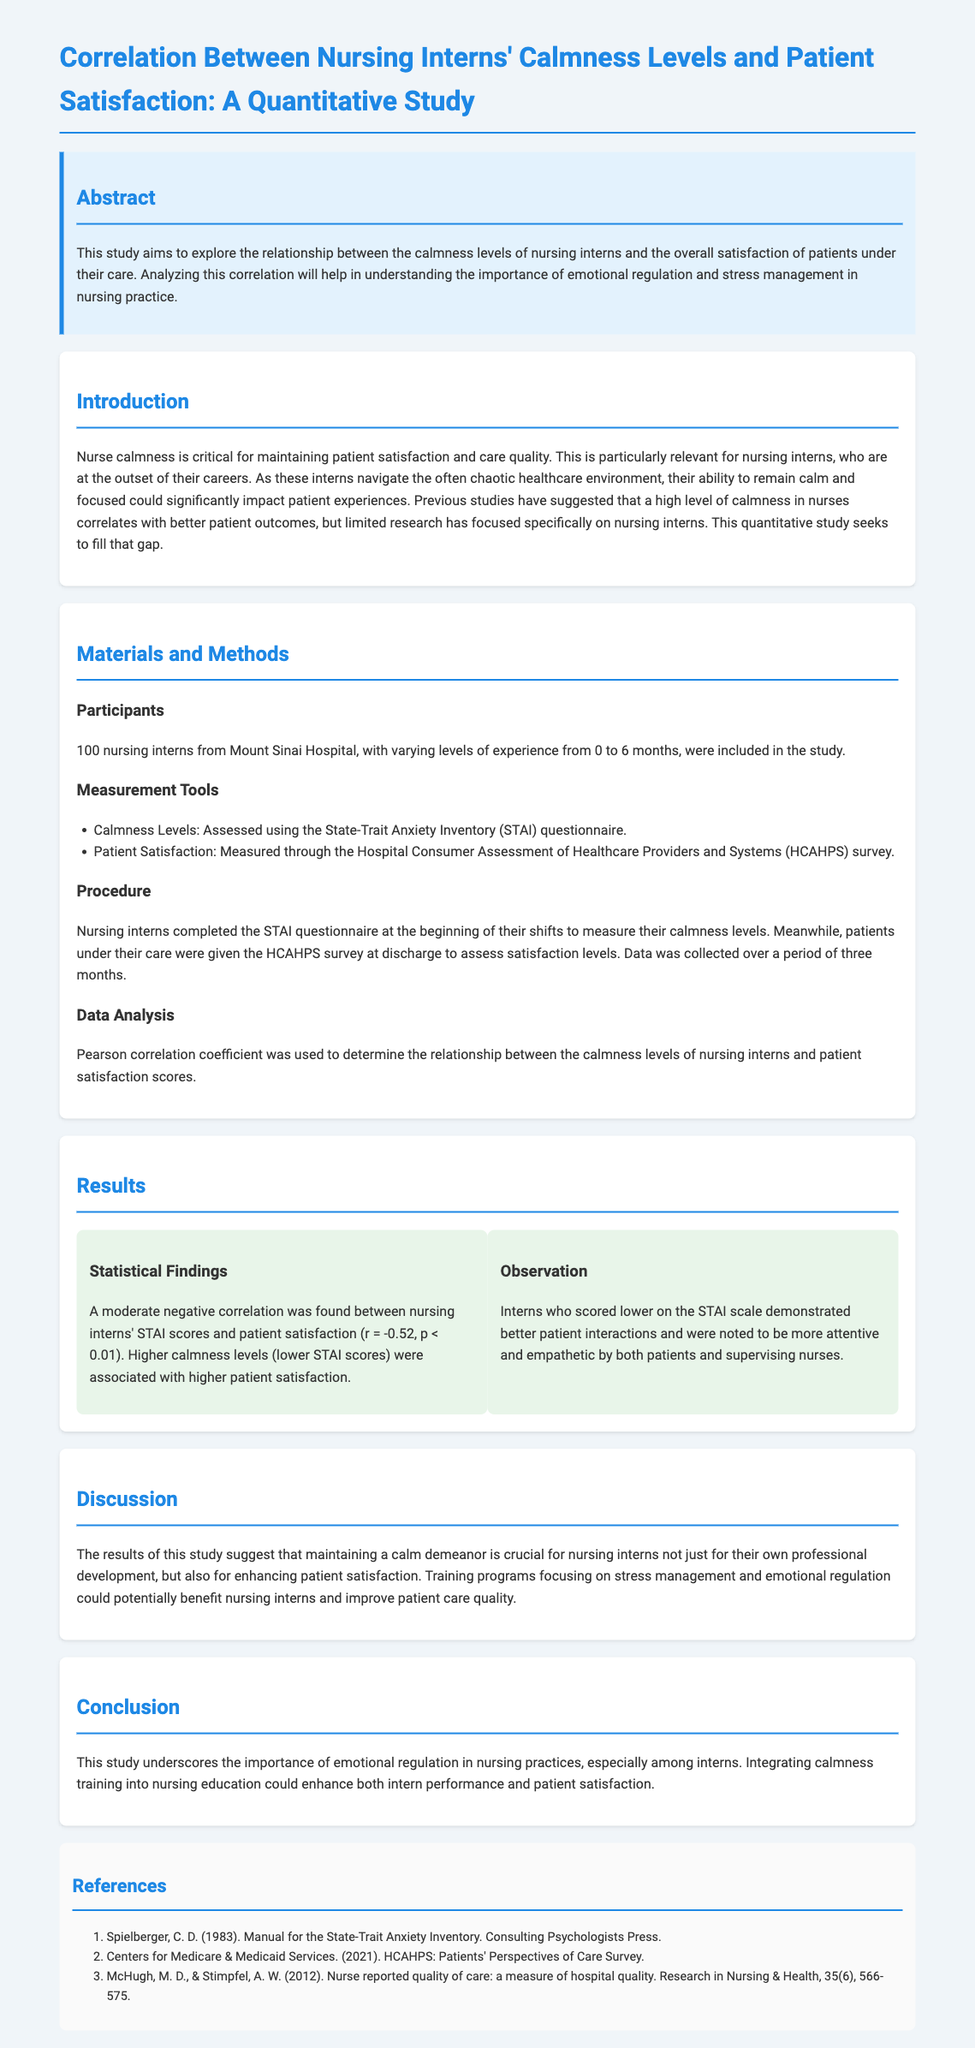what was the main objective of the study? The study aims to explore the relationship between calmness levels of nursing interns and patient satisfaction.
Answer: relationship between calmness levels of nursing interns and patient satisfaction how many nursing interns participated in the study? The document states that 100 nursing interns participated.
Answer: 100 what measurement tool was used to assess calmness levels? Calmness levels were assessed using the State-Trait Anxiety Inventory (STAI) questionnaire.
Answer: State-Trait Anxiety Inventory (STAI) questionnaire what was the correlation coefficient found in the study? The Pearson correlation coefficient found was r = -0.52.
Answer: r = -0.52 what type of correlation was identified between calmness and patient satisfaction? A moderate negative correlation was identified between calmness levels and patient satisfaction.
Answer: moderate negative correlation why is calmness considered crucial for nursing interns? The study suggests calmness is crucial for enhancing patient satisfaction and intern performance.
Answer: enhancing patient satisfaction and intern performance what was the duration of the data collection period? Data collection was conducted over a period of three months.
Answer: three months what is one recommendation for nursing education mentioned in the discussion? The study recommends integrating calmness training into nursing education.
Answer: integrating calmness training into nursing education 